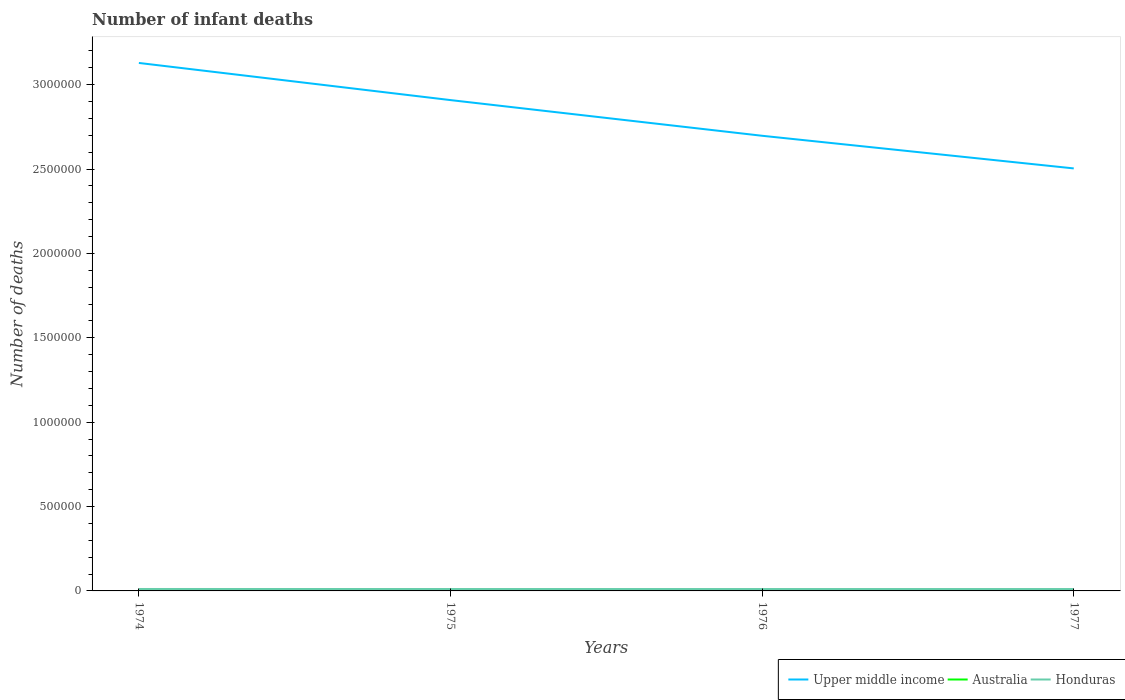How many different coloured lines are there?
Ensure brevity in your answer.  3. Does the line corresponding to Honduras intersect with the line corresponding to Upper middle income?
Ensure brevity in your answer.  No. Is the number of lines equal to the number of legend labels?
Make the answer very short. Yes. Across all years, what is the maximum number of infant deaths in Australia?
Keep it short and to the point. 3017. In which year was the number of infant deaths in Honduras maximum?
Your answer should be compact. 1977. What is the total number of infant deaths in Upper middle income in the graph?
Make the answer very short. 4.05e+05. What is the difference between the highest and the second highest number of infant deaths in Honduras?
Ensure brevity in your answer.  335. What is the difference between the highest and the lowest number of infant deaths in Upper middle income?
Your response must be concise. 2. How many lines are there?
Offer a terse response. 3. How many years are there in the graph?
Provide a succinct answer. 4. Does the graph contain grids?
Provide a short and direct response. No. Where does the legend appear in the graph?
Give a very brief answer. Bottom right. How are the legend labels stacked?
Offer a very short reply. Horizontal. What is the title of the graph?
Your response must be concise. Number of infant deaths. What is the label or title of the X-axis?
Your answer should be compact. Years. What is the label or title of the Y-axis?
Provide a short and direct response. Number of deaths. What is the Number of deaths of Upper middle income in 1974?
Offer a terse response. 3.13e+06. What is the Number of deaths in Australia in 1974?
Your answer should be compact. 4181. What is the Number of deaths of Honduras in 1974?
Your response must be concise. 1.15e+04. What is the Number of deaths of Upper middle income in 1975?
Offer a terse response. 2.91e+06. What is the Number of deaths in Australia in 1975?
Your response must be concise. 3861. What is the Number of deaths in Honduras in 1975?
Offer a terse response. 1.13e+04. What is the Number of deaths of Upper middle income in 1976?
Provide a short and direct response. 2.70e+06. What is the Number of deaths in Australia in 1976?
Give a very brief answer. 3450. What is the Number of deaths of Honduras in 1976?
Provide a short and direct response. 1.12e+04. What is the Number of deaths in Upper middle income in 1977?
Provide a short and direct response. 2.50e+06. What is the Number of deaths of Australia in 1977?
Your response must be concise. 3017. What is the Number of deaths in Honduras in 1977?
Your answer should be compact. 1.12e+04. Across all years, what is the maximum Number of deaths of Upper middle income?
Your answer should be compact. 3.13e+06. Across all years, what is the maximum Number of deaths of Australia?
Your answer should be very brief. 4181. Across all years, what is the maximum Number of deaths of Honduras?
Your answer should be very brief. 1.15e+04. Across all years, what is the minimum Number of deaths in Upper middle income?
Your answer should be very brief. 2.50e+06. Across all years, what is the minimum Number of deaths in Australia?
Keep it short and to the point. 3017. Across all years, what is the minimum Number of deaths of Honduras?
Provide a short and direct response. 1.12e+04. What is the total Number of deaths in Upper middle income in the graph?
Provide a short and direct response. 1.12e+07. What is the total Number of deaths of Australia in the graph?
Offer a terse response. 1.45e+04. What is the total Number of deaths of Honduras in the graph?
Make the answer very short. 4.52e+04. What is the difference between the Number of deaths in Upper middle income in 1974 and that in 1975?
Give a very brief answer. 2.20e+05. What is the difference between the Number of deaths in Australia in 1974 and that in 1975?
Offer a terse response. 320. What is the difference between the Number of deaths of Honduras in 1974 and that in 1975?
Ensure brevity in your answer.  182. What is the difference between the Number of deaths in Upper middle income in 1974 and that in 1976?
Keep it short and to the point. 4.32e+05. What is the difference between the Number of deaths of Australia in 1974 and that in 1976?
Provide a short and direct response. 731. What is the difference between the Number of deaths of Honduras in 1974 and that in 1976?
Offer a very short reply. 296. What is the difference between the Number of deaths in Upper middle income in 1974 and that in 1977?
Keep it short and to the point. 6.25e+05. What is the difference between the Number of deaths of Australia in 1974 and that in 1977?
Provide a succinct answer. 1164. What is the difference between the Number of deaths of Honduras in 1974 and that in 1977?
Offer a terse response. 335. What is the difference between the Number of deaths in Upper middle income in 1975 and that in 1976?
Provide a short and direct response. 2.11e+05. What is the difference between the Number of deaths in Australia in 1975 and that in 1976?
Provide a short and direct response. 411. What is the difference between the Number of deaths in Honduras in 1975 and that in 1976?
Make the answer very short. 114. What is the difference between the Number of deaths of Upper middle income in 1975 and that in 1977?
Offer a terse response. 4.05e+05. What is the difference between the Number of deaths of Australia in 1975 and that in 1977?
Offer a very short reply. 844. What is the difference between the Number of deaths in Honduras in 1975 and that in 1977?
Offer a very short reply. 153. What is the difference between the Number of deaths of Upper middle income in 1976 and that in 1977?
Offer a very short reply. 1.93e+05. What is the difference between the Number of deaths in Australia in 1976 and that in 1977?
Make the answer very short. 433. What is the difference between the Number of deaths of Upper middle income in 1974 and the Number of deaths of Australia in 1975?
Offer a terse response. 3.12e+06. What is the difference between the Number of deaths of Upper middle income in 1974 and the Number of deaths of Honduras in 1975?
Offer a very short reply. 3.12e+06. What is the difference between the Number of deaths of Australia in 1974 and the Number of deaths of Honduras in 1975?
Provide a succinct answer. -7128. What is the difference between the Number of deaths in Upper middle income in 1974 and the Number of deaths in Australia in 1976?
Your response must be concise. 3.13e+06. What is the difference between the Number of deaths in Upper middle income in 1974 and the Number of deaths in Honduras in 1976?
Provide a succinct answer. 3.12e+06. What is the difference between the Number of deaths in Australia in 1974 and the Number of deaths in Honduras in 1976?
Give a very brief answer. -7014. What is the difference between the Number of deaths of Upper middle income in 1974 and the Number of deaths of Australia in 1977?
Your answer should be very brief. 3.13e+06. What is the difference between the Number of deaths of Upper middle income in 1974 and the Number of deaths of Honduras in 1977?
Provide a short and direct response. 3.12e+06. What is the difference between the Number of deaths of Australia in 1974 and the Number of deaths of Honduras in 1977?
Ensure brevity in your answer.  -6975. What is the difference between the Number of deaths of Upper middle income in 1975 and the Number of deaths of Australia in 1976?
Your answer should be very brief. 2.91e+06. What is the difference between the Number of deaths of Upper middle income in 1975 and the Number of deaths of Honduras in 1976?
Ensure brevity in your answer.  2.90e+06. What is the difference between the Number of deaths in Australia in 1975 and the Number of deaths in Honduras in 1976?
Your answer should be compact. -7334. What is the difference between the Number of deaths of Upper middle income in 1975 and the Number of deaths of Australia in 1977?
Provide a succinct answer. 2.91e+06. What is the difference between the Number of deaths of Upper middle income in 1975 and the Number of deaths of Honduras in 1977?
Ensure brevity in your answer.  2.90e+06. What is the difference between the Number of deaths of Australia in 1975 and the Number of deaths of Honduras in 1977?
Your response must be concise. -7295. What is the difference between the Number of deaths of Upper middle income in 1976 and the Number of deaths of Australia in 1977?
Your answer should be compact. 2.69e+06. What is the difference between the Number of deaths of Upper middle income in 1976 and the Number of deaths of Honduras in 1977?
Provide a short and direct response. 2.69e+06. What is the difference between the Number of deaths in Australia in 1976 and the Number of deaths in Honduras in 1977?
Your response must be concise. -7706. What is the average Number of deaths in Upper middle income per year?
Give a very brief answer. 2.81e+06. What is the average Number of deaths in Australia per year?
Ensure brevity in your answer.  3627.25. What is the average Number of deaths of Honduras per year?
Your answer should be compact. 1.13e+04. In the year 1974, what is the difference between the Number of deaths of Upper middle income and Number of deaths of Australia?
Ensure brevity in your answer.  3.12e+06. In the year 1974, what is the difference between the Number of deaths in Upper middle income and Number of deaths in Honduras?
Your answer should be very brief. 3.12e+06. In the year 1974, what is the difference between the Number of deaths of Australia and Number of deaths of Honduras?
Provide a short and direct response. -7310. In the year 1975, what is the difference between the Number of deaths in Upper middle income and Number of deaths in Australia?
Your answer should be compact. 2.90e+06. In the year 1975, what is the difference between the Number of deaths of Upper middle income and Number of deaths of Honduras?
Your answer should be compact. 2.90e+06. In the year 1975, what is the difference between the Number of deaths in Australia and Number of deaths in Honduras?
Provide a succinct answer. -7448. In the year 1976, what is the difference between the Number of deaths of Upper middle income and Number of deaths of Australia?
Offer a terse response. 2.69e+06. In the year 1976, what is the difference between the Number of deaths of Upper middle income and Number of deaths of Honduras?
Provide a short and direct response. 2.69e+06. In the year 1976, what is the difference between the Number of deaths of Australia and Number of deaths of Honduras?
Offer a terse response. -7745. In the year 1977, what is the difference between the Number of deaths of Upper middle income and Number of deaths of Australia?
Provide a short and direct response. 2.50e+06. In the year 1977, what is the difference between the Number of deaths of Upper middle income and Number of deaths of Honduras?
Offer a very short reply. 2.49e+06. In the year 1977, what is the difference between the Number of deaths in Australia and Number of deaths in Honduras?
Your answer should be compact. -8139. What is the ratio of the Number of deaths in Upper middle income in 1974 to that in 1975?
Make the answer very short. 1.08. What is the ratio of the Number of deaths in Australia in 1974 to that in 1975?
Give a very brief answer. 1.08. What is the ratio of the Number of deaths in Honduras in 1974 to that in 1975?
Give a very brief answer. 1.02. What is the ratio of the Number of deaths in Upper middle income in 1974 to that in 1976?
Make the answer very short. 1.16. What is the ratio of the Number of deaths in Australia in 1974 to that in 1976?
Give a very brief answer. 1.21. What is the ratio of the Number of deaths in Honduras in 1974 to that in 1976?
Your answer should be compact. 1.03. What is the ratio of the Number of deaths in Upper middle income in 1974 to that in 1977?
Keep it short and to the point. 1.25. What is the ratio of the Number of deaths in Australia in 1974 to that in 1977?
Provide a short and direct response. 1.39. What is the ratio of the Number of deaths of Honduras in 1974 to that in 1977?
Give a very brief answer. 1.03. What is the ratio of the Number of deaths of Upper middle income in 1975 to that in 1976?
Ensure brevity in your answer.  1.08. What is the ratio of the Number of deaths of Australia in 1975 to that in 1976?
Your answer should be very brief. 1.12. What is the ratio of the Number of deaths of Honduras in 1975 to that in 1976?
Your answer should be very brief. 1.01. What is the ratio of the Number of deaths in Upper middle income in 1975 to that in 1977?
Give a very brief answer. 1.16. What is the ratio of the Number of deaths in Australia in 1975 to that in 1977?
Give a very brief answer. 1.28. What is the ratio of the Number of deaths in Honduras in 1975 to that in 1977?
Offer a very short reply. 1.01. What is the ratio of the Number of deaths in Upper middle income in 1976 to that in 1977?
Ensure brevity in your answer.  1.08. What is the ratio of the Number of deaths in Australia in 1976 to that in 1977?
Your answer should be compact. 1.14. What is the difference between the highest and the second highest Number of deaths of Upper middle income?
Provide a short and direct response. 2.20e+05. What is the difference between the highest and the second highest Number of deaths of Australia?
Offer a terse response. 320. What is the difference between the highest and the second highest Number of deaths in Honduras?
Your answer should be very brief. 182. What is the difference between the highest and the lowest Number of deaths of Upper middle income?
Provide a succinct answer. 6.25e+05. What is the difference between the highest and the lowest Number of deaths of Australia?
Your answer should be very brief. 1164. What is the difference between the highest and the lowest Number of deaths of Honduras?
Your answer should be very brief. 335. 